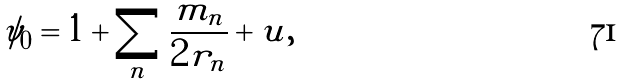Convert formula to latex. <formula><loc_0><loc_0><loc_500><loc_500>\psi _ { 0 } = 1 + \sum _ { n } \frac { m _ { n } } { 2 r _ { n } } + u ,</formula> 